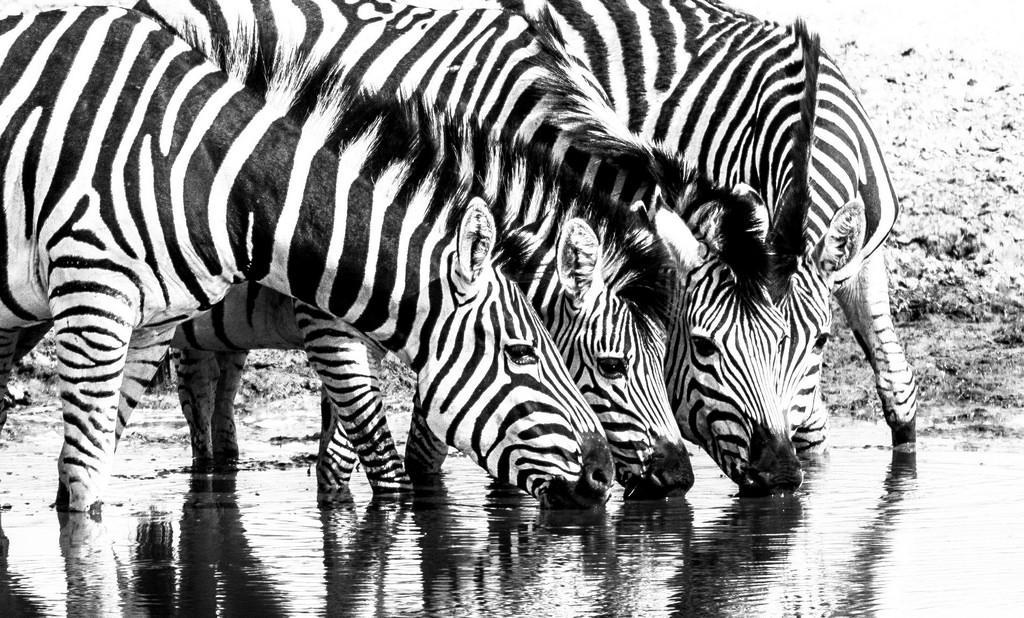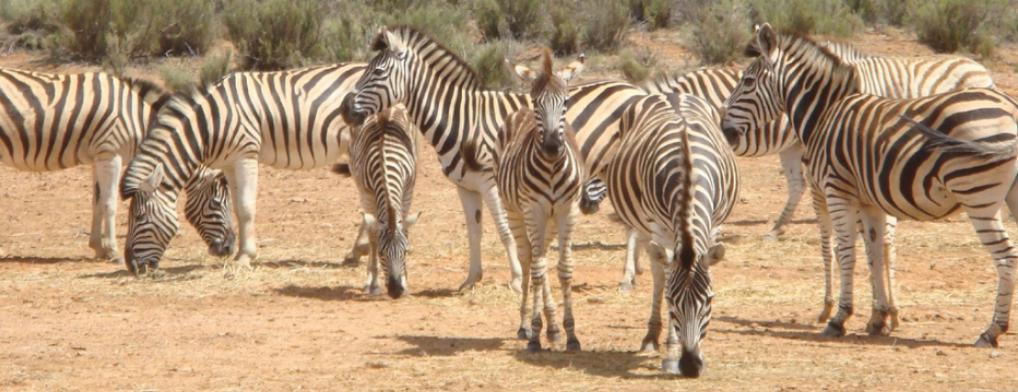The first image is the image on the left, the second image is the image on the right. Evaluate the accuracy of this statement regarding the images: "There are two to three zebra facing left moving forward.". Is it true? Answer yes or no. No. 